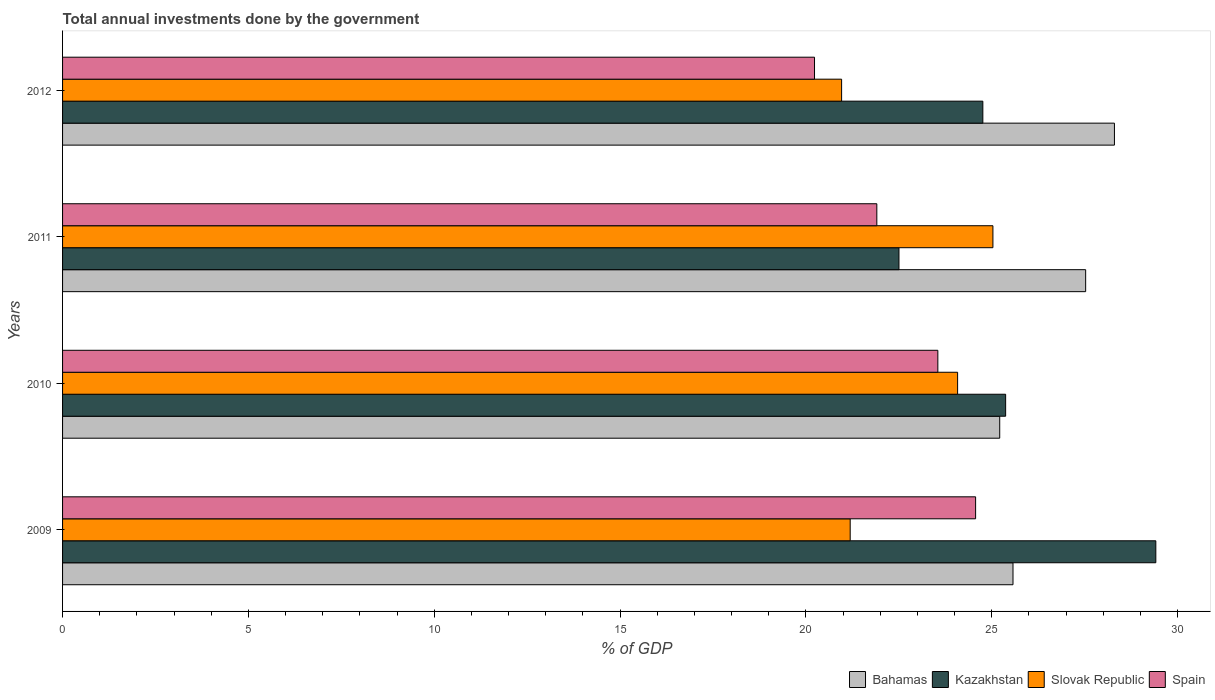How many different coloured bars are there?
Offer a terse response. 4. Are the number of bars per tick equal to the number of legend labels?
Keep it short and to the point. Yes. What is the total annual investments done by the government in Bahamas in 2011?
Offer a terse response. 27.53. Across all years, what is the maximum total annual investments done by the government in Spain?
Ensure brevity in your answer.  24.57. Across all years, what is the minimum total annual investments done by the government in Slovak Republic?
Provide a short and direct response. 20.96. What is the total total annual investments done by the government in Bahamas in the graph?
Offer a terse response. 106.61. What is the difference between the total annual investments done by the government in Spain in 2009 and that in 2010?
Provide a short and direct response. 1.02. What is the difference between the total annual investments done by the government in Spain in 2010 and the total annual investments done by the government in Bahamas in 2011?
Provide a succinct answer. -3.98. What is the average total annual investments done by the government in Slovak Republic per year?
Your response must be concise. 22.82. In the year 2010, what is the difference between the total annual investments done by the government in Spain and total annual investments done by the government in Bahamas?
Your response must be concise. -1.67. What is the ratio of the total annual investments done by the government in Spain in 2011 to that in 2012?
Keep it short and to the point. 1.08. What is the difference between the highest and the second highest total annual investments done by the government in Bahamas?
Make the answer very short. 0.77. What is the difference between the highest and the lowest total annual investments done by the government in Kazakhstan?
Your answer should be compact. 6.91. In how many years, is the total annual investments done by the government in Slovak Republic greater than the average total annual investments done by the government in Slovak Republic taken over all years?
Your response must be concise. 2. What does the 3rd bar from the top in 2010 represents?
Make the answer very short. Kazakhstan. What does the 2nd bar from the bottom in 2009 represents?
Your response must be concise. Kazakhstan. How many bars are there?
Your answer should be very brief. 16. Are the values on the major ticks of X-axis written in scientific E-notation?
Provide a short and direct response. No. Does the graph contain any zero values?
Make the answer very short. No. How many legend labels are there?
Offer a terse response. 4. How are the legend labels stacked?
Keep it short and to the point. Horizontal. What is the title of the graph?
Ensure brevity in your answer.  Total annual investments done by the government. What is the label or title of the X-axis?
Provide a short and direct response. % of GDP. What is the label or title of the Y-axis?
Provide a short and direct response. Years. What is the % of GDP of Bahamas in 2009?
Your response must be concise. 25.57. What is the % of GDP in Kazakhstan in 2009?
Your response must be concise. 29.41. What is the % of GDP of Slovak Republic in 2009?
Ensure brevity in your answer.  21.19. What is the % of GDP of Spain in 2009?
Make the answer very short. 24.57. What is the % of GDP of Bahamas in 2010?
Make the answer very short. 25.21. What is the % of GDP in Kazakhstan in 2010?
Make the answer very short. 25.37. What is the % of GDP of Slovak Republic in 2010?
Keep it short and to the point. 24.08. What is the % of GDP in Spain in 2010?
Your answer should be compact. 23.55. What is the % of GDP of Bahamas in 2011?
Ensure brevity in your answer.  27.53. What is the % of GDP in Kazakhstan in 2011?
Keep it short and to the point. 22.5. What is the % of GDP in Slovak Republic in 2011?
Your answer should be very brief. 25.03. What is the % of GDP in Spain in 2011?
Ensure brevity in your answer.  21.91. What is the % of GDP in Bahamas in 2012?
Provide a succinct answer. 28.3. What is the % of GDP in Kazakhstan in 2012?
Offer a terse response. 24.76. What is the % of GDP of Slovak Republic in 2012?
Offer a terse response. 20.96. What is the % of GDP of Spain in 2012?
Your answer should be compact. 20.23. Across all years, what is the maximum % of GDP in Bahamas?
Provide a succinct answer. 28.3. Across all years, what is the maximum % of GDP of Kazakhstan?
Your answer should be compact. 29.41. Across all years, what is the maximum % of GDP in Slovak Republic?
Keep it short and to the point. 25.03. Across all years, what is the maximum % of GDP of Spain?
Offer a terse response. 24.57. Across all years, what is the minimum % of GDP of Bahamas?
Ensure brevity in your answer.  25.21. Across all years, what is the minimum % of GDP of Kazakhstan?
Ensure brevity in your answer.  22.5. Across all years, what is the minimum % of GDP of Slovak Republic?
Offer a terse response. 20.96. Across all years, what is the minimum % of GDP in Spain?
Provide a short and direct response. 20.23. What is the total % of GDP of Bahamas in the graph?
Provide a succinct answer. 106.61. What is the total % of GDP of Kazakhstan in the graph?
Offer a very short reply. 102.05. What is the total % of GDP of Slovak Republic in the graph?
Offer a very short reply. 91.26. What is the total % of GDP of Spain in the graph?
Offer a terse response. 90.25. What is the difference between the % of GDP in Bahamas in 2009 and that in 2010?
Give a very brief answer. 0.36. What is the difference between the % of GDP of Kazakhstan in 2009 and that in 2010?
Offer a terse response. 4.04. What is the difference between the % of GDP of Slovak Republic in 2009 and that in 2010?
Your answer should be very brief. -2.89. What is the difference between the % of GDP of Spain in 2009 and that in 2010?
Provide a succinct answer. 1.02. What is the difference between the % of GDP in Bahamas in 2009 and that in 2011?
Keep it short and to the point. -1.95. What is the difference between the % of GDP in Kazakhstan in 2009 and that in 2011?
Your answer should be compact. 6.91. What is the difference between the % of GDP of Slovak Republic in 2009 and that in 2011?
Your response must be concise. -3.84. What is the difference between the % of GDP of Spain in 2009 and that in 2011?
Your answer should be very brief. 2.66. What is the difference between the % of GDP of Bahamas in 2009 and that in 2012?
Your answer should be very brief. -2.73. What is the difference between the % of GDP of Kazakhstan in 2009 and that in 2012?
Provide a short and direct response. 4.65. What is the difference between the % of GDP of Slovak Republic in 2009 and that in 2012?
Ensure brevity in your answer.  0.23. What is the difference between the % of GDP of Spain in 2009 and that in 2012?
Provide a short and direct response. 4.33. What is the difference between the % of GDP in Bahamas in 2010 and that in 2011?
Give a very brief answer. -2.31. What is the difference between the % of GDP in Kazakhstan in 2010 and that in 2011?
Provide a short and direct response. 2.87. What is the difference between the % of GDP of Slovak Republic in 2010 and that in 2011?
Provide a succinct answer. -0.95. What is the difference between the % of GDP in Spain in 2010 and that in 2011?
Give a very brief answer. 1.64. What is the difference between the % of GDP of Bahamas in 2010 and that in 2012?
Ensure brevity in your answer.  -3.09. What is the difference between the % of GDP in Kazakhstan in 2010 and that in 2012?
Provide a succinct answer. 0.61. What is the difference between the % of GDP of Slovak Republic in 2010 and that in 2012?
Your response must be concise. 3.12. What is the difference between the % of GDP of Spain in 2010 and that in 2012?
Your answer should be very brief. 3.32. What is the difference between the % of GDP in Bahamas in 2011 and that in 2012?
Ensure brevity in your answer.  -0.77. What is the difference between the % of GDP of Kazakhstan in 2011 and that in 2012?
Give a very brief answer. -2.26. What is the difference between the % of GDP in Slovak Republic in 2011 and that in 2012?
Provide a succinct answer. 4.07. What is the difference between the % of GDP of Spain in 2011 and that in 2012?
Provide a short and direct response. 1.68. What is the difference between the % of GDP in Bahamas in 2009 and the % of GDP in Kazakhstan in 2010?
Offer a terse response. 0.2. What is the difference between the % of GDP of Bahamas in 2009 and the % of GDP of Slovak Republic in 2010?
Keep it short and to the point. 1.49. What is the difference between the % of GDP in Bahamas in 2009 and the % of GDP in Spain in 2010?
Your response must be concise. 2.02. What is the difference between the % of GDP in Kazakhstan in 2009 and the % of GDP in Slovak Republic in 2010?
Ensure brevity in your answer.  5.33. What is the difference between the % of GDP in Kazakhstan in 2009 and the % of GDP in Spain in 2010?
Ensure brevity in your answer.  5.87. What is the difference between the % of GDP in Slovak Republic in 2009 and the % of GDP in Spain in 2010?
Give a very brief answer. -2.36. What is the difference between the % of GDP of Bahamas in 2009 and the % of GDP of Kazakhstan in 2011?
Provide a short and direct response. 3.07. What is the difference between the % of GDP of Bahamas in 2009 and the % of GDP of Slovak Republic in 2011?
Offer a terse response. 0.54. What is the difference between the % of GDP in Bahamas in 2009 and the % of GDP in Spain in 2011?
Ensure brevity in your answer.  3.66. What is the difference between the % of GDP in Kazakhstan in 2009 and the % of GDP in Slovak Republic in 2011?
Your response must be concise. 4.38. What is the difference between the % of GDP in Kazakhstan in 2009 and the % of GDP in Spain in 2011?
Your answer should be very brief. 7.51. What is the difference between the % of GDP in Slovak Republic in 2009 and the % of GDP in Spain in 2011?
Ensure brevity in your answer.  -0.72. What is the difference between the % of GDP in Bahamas in 2009 and the % of GDP in Kazakhstan in 2012?
Offer a very short reply. 0.81. What is the difference between the % of GDP in Bahamas in 2009 and the % of GDP in Slovak Republic in 2012?
Keep it short and to the point. 4.61. What is the difference between the % of GDP of Bahamas in 2009 and the % of GDP of Spain in 2012?
Keep it short and to the point. 5.34. What is the difference between the % of GDP in Kazakhstan in 2009 and the % of GDP in Slovak Republic in 2012?
Your response must be concise. 8.45. What is the difference between the % of GDP of Kazakhstan in 2009 and the % of GDP of Spain in 2012?
Your answer should be compact. 9.18. What is the difference between the % of GDP in Slovak Republic in 2009 and the % of GDP in Spain in 2012?
Provide a succinct answer. 0.96. What is the difference between the % of GDP in Bahamas in 2010 and the % of GDP in Kazakhstan in 2011?
Your answer should be very brief. 2.71. What is the difference between the % of GDP of Bahamas in 2010 and the % of GDP of Slovak Republic in 2011?
Provide a short and direct response. 0.18. What is the difference between the % of GDP in Bahamas in 2010 and the % of GDP in Spain in 2011?
Your answer should be compact. 3.31. What is the difference between the % of GDP in Kazakhstan in 2010 and the % of GDP in Slovak Republic in 2011?
Give a very brief answer. 0.34. What is the difference between the % of GDP of Kazakhstan in 2010 and the % of GDP of Spain in 2011?
Your answer should be compact. 3.47. What is the difference between the % of GDP of Slovak Republic in 2010 and the % of GDP of Spain in 2011?
Provide a short and direct response. 2.17. What is the difference between the % of GDP in Bahamas in 2010 and the % of GDP in Kazakhstan in 2012?
Provide a short and direct response. 0.45. What is the difference between the % of GDP of Bahamas in 2010 and the % of GDP of Slovak Republic in 2012?
Offer a very short reply. 4.25. What is the difference between the % of GDP in Bahamas in 2010 and the % of GDP in Spain in 2012?
Give a very brief answer. 4.98. What is the difference between the % of GDP in Kazakhstan in 2010 and the % of GDP in Slovak Republic in 2012?
Offer a terse response. 4.41. What is the difference between the % of GDP in Kazakhstan in 2010 and the % of GDP in Spain in 2012?
Make the answer very short. 5.14. What is the difference between the % of GDP in Slovak Republic in 2010 and the % of GDP in Spain in 2012?
Make the answer very short. 3.85. What is the difference between the % of GDP in Bahamas in 2011 and the % of GDP in Kazakhstan in 2012?
Your response must be concise. 2.77. What is the difference between the % of GDP of Bahamas in 2011 and the % of GDP of Slovak Republic in 2012?
Ensure brevity in your answer.  6.57. What is the difference between the % of GDP of Bahamas in 2011 and the % of GDP of Spain in 2012?
Make the answer very short. 7.3. What is the difference between the % of GDP in Kazakhstan in 2011 and the % of GDP in Slovak Republic in 2012?
Keep it short and to the point. 1.54. What is the difference between the % of GDP of Kazakhstan in 2011 and the % of GDP of Spain in 2012?
Your answer should be very brief. 2.27. What is the difference between the % of GDP of Slovak Republic in 2011 and the % of GDP of Spain in 2012?
Offer a terse response. 4.8. What is the average % of GDP of Bahamas per year?
Provide a succinct answer. 26.65. What is the average % of GDP in Kazakhstan per year?
Your response must be concise. 25.51. What is the average % of GDP of Slovak Republic per year?
Give a very brief answer. 22.82. What is the average % of GDP in Spain per year?
Make the answer very short. 22.56. In the year 2009, what is the difference between the % of GDP in Bahamas and % of GDP in Kazakhstan?
Ensure brevity in your answer.  -3.84. In the year 2009, what is the difference between the % of GDP of Bahamas and % of GDP of Slovak Republic?
Offer a terse response. 4.38. In the year 2009, what is the difference between the % of GDP of Bahamas and % of GDP of Spain?
Ensure brevity in your answer.  1.01. In the year 2009, what is the difference between the % of GDP of Kazakhstan and % of GDP of Slovak Republic?
Your answer should be very brief. 8.22. In the year 2009, what is the difference between the % of GDP in Kazakhstan and % of GDP in Spain?
Provide a short and direct response. 4.85. In the year 2009, what is the difference between the % of GDP of Slovak Republic and % of GDP of Spain?
Give a very brief answer. -3.37. In the year 2010, what is the difference between the % of GDP in Bahamas and % of GDP in Kazakhstan?
Make the answer very short. -0.16. In the year 2010, what is the difference between the % of GDP of Bahamas and % of GDP of Slovak Republic?
Keep it short and to the point. 1.13. In the year 2010, what is the difference between the % of GDP in Bahamas and % of GDP in Spain?
Provide a succinct answer. 1.67. In the year 2010, what is the difference between the % of GDP of Kazakhstan and % of GDP of Slovak Republic?
Offer a terse response. 1.29. In the year 2010, what is the difference between the % of GDP in Kazakhstan and % of GDP in Spain?
Offer a very short reply. 1.82. In the year 2010, what is the difference between the % of GDP of Slovak Republic and % of GDP of Spain?
Your answer should be very brief. 0.53. In the year 2011, what is the difference between the % of GDP in Bahamas and % of GDP in Kazakhstan?
Offer a very short reply. 5.02. In the year 2011, what is the difference between the % of GDP of Bahamas and % of GDP of Slovak Republic?
Your answer should be compact. 2.5. In the year 2011, what is the difference between the % of GDP in Bahamas and % of GDP in Spain?
Your answer should be compact. 5.62. In the year 2011, what is the difference between the % of GDP of Kazakhstan and % of GDP of Slovak Republic?
Give a very brief answer. -2.53. In the year 2011, what is the difference between the % of GDP in Kazakhstan and % of GDP in Spain?
Provide a succinct answer. 0.6. In the year 2011, what is the difference between the % of GDP in Slovak Republic and % of GDP in Spain?
Offer a terse response. 3.12. In the year 2012, what is the difference between the % of GDP in Bahamas and % of GDP in Kazakhstan?
Provide a succinct answer. 3.54. In the year 2012, what is the difference between the % of GDP of Bahamas and % of GDP of Slovak Republic?
Your answer should be very brief. 7.34. In the year 2012, what is the difference between the % of GDP of Bahamas and % of GDP of Spain?
Your answer should be compact. 8.07. In the year 2012, what is the difference between the % of GDP in Kazakhstan and % of GDP in Spain?
Your answer should be compact. 4.53. In the year 2012, what is the difference between the % of GDP of Slovak Republic and % of GDP of Spain?
Your answer should be compact. 0.73. What is the ratio of the % of GDP of Bahamas in 2009 to that in 2010?
Your response must be concise. 1.01. What is the ratio of the % of GDP of Kazakhstan in 2009 to that in 2010?
Your answer should be compact. 1.16. What is the ratio of the % of GDP in Slovak Republic in 2009 to that in 2010?
Give a very brief answer. 0.88. What is the ratio of the % of GDP of Spain in 2009 to that in 2010?
Offer a terse response. 1.04. What is the ratio of the % of GDP in Bahamas in 2009 to that in 2011?
Offer a terse response. 0.93. What is the ratio of the % of GDP in Kazakhstan in 2009 to that in 2011?
Provide a succinct answer. 1.31. What is the ratio of the % of GDP in Slovak Republic in 2009 to that in 2011?
Your answer should be compact. 0.85. What is the ratio of the % of GDP of Spain in 2009 to that in 2011?
Your answer should be very brief. 1.12. What is the ratio of the % of GDP of Bahamas in 2009 to that in 2012?
Make the answer very short. 0.9. What is the ratio of the % of GDP of Kazakhstan in 2009 to that in 2012?
Provide a short and direct response. 1.19. What is the ratio of the % of GDP in Slovak Republic in 2009 to that in 2012?
Your response must be concise. 1.01. What is the ratio of the % of GDP in Spain in 2009 to that in 2012?
Your answer should be compact. 1.21. What is the ratio of the % of GDP in Bahamas in 2010 to that in 2011?
Your response must be concise. 0.92. What is the ratio of the % of GDP in Kazakhstan in 2010 to that in 2011?
Your answer should be very brief. 1.13. What is the ratio of the % of GDP in Slovak Republic in 2010 to that in 2011?
Provide a short and direct response. 0.96. What is the ratio of the % of GDP in Spain in 2010 to that in 2011?
Provide a succinct answer. 1.07. What is the ratio of the % of GDP in Bahamas in 2010 to that in 2012?
Provide a succinct answer. 0.89. What is the ratio of the % of GDP in Kazakhstan in 2010 to that in 2012?
Give a very brief answer. 1.02. What is the ratio of the % of GDP of Slovak Republic in 2010 to that in 2012?
Provide a short and direct response. 1.15. What is the ratio of the % of GDP of Spain in 2010 to that in 2012?
Ensure brevity in your answer.  1.16. What is the ratio of the % of GDP in Bahamas in 2011 to that in 2012?
Keep it short and to the point. 0.97. What is the ratio of the % of GDP of Kazakhstan in 2011 to that in 2012?
Offer a terse response. 0.91. What is the ratio of the % of GDP in Slovak Republic in 2011 to that in 2012?
Your response must be concise. 1.19. What is the ratio of the % of GDP of Spain in 2011 to that in 2012?
Give a very brief answer. 1.08. What is the difference between the highest and the second highest % of GDP of Bahamas?
Keep it short and to the point. 0.77. What is the difference between the highest and the second highest % of GDP in Kazakhstan?
Provide a succinct answer. 4.04. What is the difference between the highest and the second highest % of GDP in Slovak Republic?
Make the answer very short. 0.95. What is the difference between the highest and the second highest % of GDP in Spain?
Your response must be concise. 1.02. What is the difference between the highest and the lowest % of GDP of Bahamas?
Make the answer very short. 3.09. What is the difference between the highest and the lowest % of GDP of Kazakhstan?
Ensure brevity in your answer.  6.91. What is the difference between the highest and the lowest % of GDP in Slovak Republic?
Your answer should be very brief. 4.07. What is the difference between the highest and the lowest % of GDP of Spain?
Offer a terse response. 4.33. 